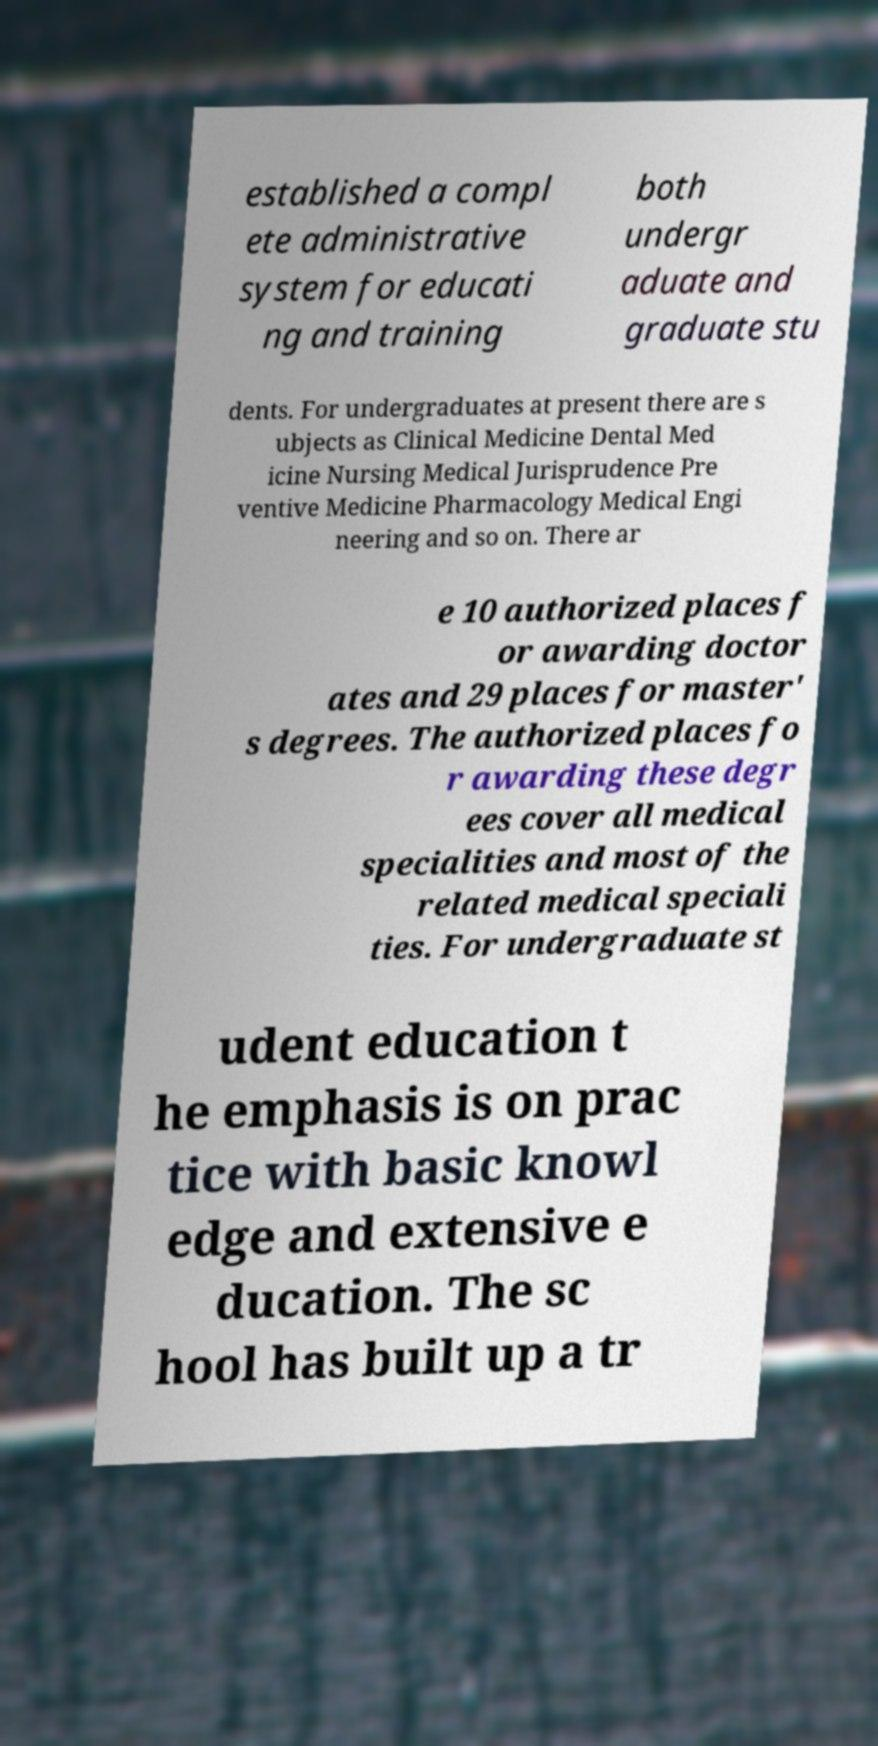For documentation purposes, I need the text within this image transcribed. Could you provide that? established a compl ete administrative system for educati ng and training both undergr aduate and graduate stu dents. For undergraduates at present there are s ubjects as Clinical Medicine Dental Med icine Nursing Medical Jurisprudence Pre ventive Medicine Pharmacology Medical Engi neering and so on. There ar e 10 authorized places f or awarding doctor ates and 29 places for master' s degrees. The authorized places fo r awarding these degr ees cover all medical specialities and most of the related medical speciali ties. For undergraduate st udent education t he emphasis is on prac tice with basic knowl edge and extensive e ducation. The sc hool has built up a tr 